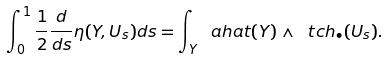Convert formula to latex. <formula><loc_0><loc_0><loc_500><loc_500>\int _ { 0 } ^ { 1 } \frac { 1 } { 2 } \frac { d } { d s } \eta ( Y , U _ { s } ) d s = \int _ { Y } \ a h a t ( Y ) \wedge \ t c h _ { \bullet } ( U _ { s } ) .</formula> 